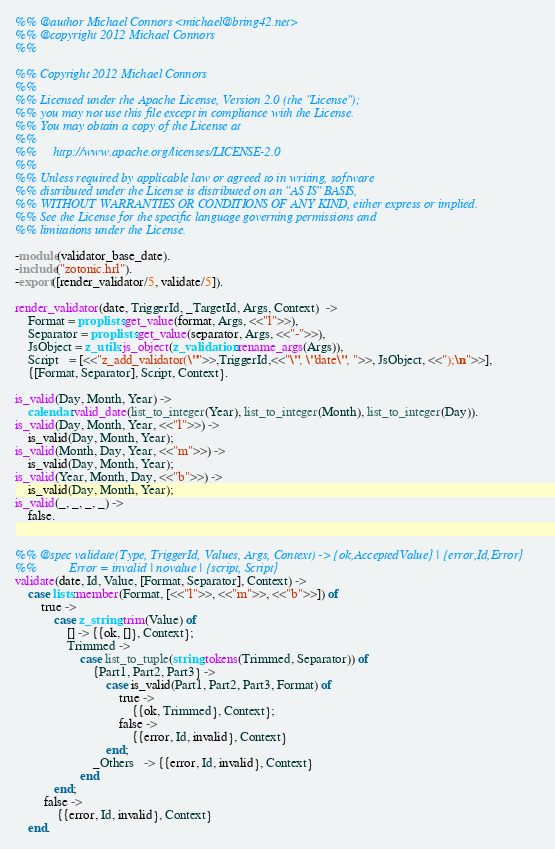<code> <loc_0><loc_0><loc_500><loc_500><_Erlang_>%% @author Michael Connors <michael@bring42.net>
%% @copyright 2012 Michael Connors
%%

%% Copyright 2012 Michael Connors
%%
%% Licensed under the Apache License, Version 2.0 (the "License");
%% you may not use this file except in compliance with the License.
%% You may obtain a copy of the License at
%%
%%     http://www.apache.org/licenses/LICENSE-2.0
%%
%% Unless required by applicable law or agreed to in writing, software
%% distributed under the License is distributed on an "AS IS" BASIS,
%% WITHOUT WARRANTIES OR CONDITIONS OF ANY KIND, either express or implied.
%% See the License for the specific language governing permissions and
%% limitations under the License.

-module(validator_base_date).
-include("zotonic.hrl").
-export([render_validator/5, validate/5]).

render_validator(date, TriggerId, _TargetId, Args, Context)  ->
    Format = proplists:get_value(format, Args, <<"l">>),
    Separator = proplists:get_value(separator, Args, <<"-">>),
    JsObject = z_utils:js_object(z_validation:rename_args(Args)),
    Script   = [<<"z_add_validator(\"">>,TriggerId,<<"\", \"date\", ">>, JsObject, <<");\n">>],
    {[Format, Separator], Script, Context}.

is_valid(Day, Month, Year) ->
    calendar:valid_date(list_to_integer(Year), list_to_integer(Month), list_to_integer(Day)).
is_valid(Day, Month, Year, <<"l">>) ->
    is_valid(Day, Month, Year);
is_valid(Month, Day, Year, <<"m">>) ->
    is_valid(Day, Month, Year);
is_valid(Year, Month, Day, <<"b">>) ->
    is_valid(Day, Month, Year);
is_valid(_, _, _, _) ->
    false.


%% @spec validate(Type, TriggerId, Values, Args, Context) -> {ok,AcceptedValue} | {error,Id,Error}
%%          Error = invalid | novalue | {script, Script}
validate(date, Id, Value, [Format, Separator], Context) ->
    case lists:member(Format, [<<"l">>, <<"m">>, <<"b">>]) of
        true ->
            case z_string:trim(Value) of
                [] -> {{ok, []}, Context};
                Trimmed ->
                    case list_to_tuple(string:tokens(Trimmed, Separator)) of
                        {Part1, Part2, Part3} ->
                            case is_valid(Part1, Part2, Part3, Format) of
                                true ->
                                    {{ok, Trimmed}, Context};
                                false ->
                                    {{error, Id, invalid}, Context}
                            end;
                        _Others   -> {{error, Id, invalid}, Context}
                    end
            end;
         false ->
             {{error, Id, invalid}, Context}
    end.
</code> 